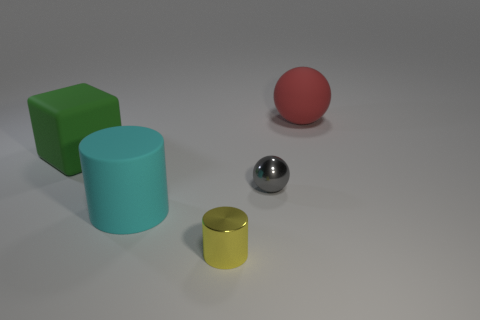Are there any big green matte blocks to the right of the tiny gray sphere?
Give a very brief answer. No. Are there more red matte things that are behind the tiny metal cylinder than big yellow cylinders?
Provide a succinct answer. Yes. There is a matte sphere that is the same size as the matte cylinder; what is its color?
Your answer should be very brief. Red. Are there any green rubber things that are behind the sphere left of the red matte object?
Your answer should be very brief. Yes. There is a sphere that is behind the matte block; what is its material?
Offer a terse response. Rubber. Does the small thing that is behind the yellow metallic cylinder have the same material as the cylinder behind the yellow metallic cylinder?
Your answer should be compact. No. Is the number of large cylinders that are behind the red thing the same as the number of small yellow cylinders that are behind the yellow metal object?
Your answer should be compact. Yes. How many yellow things have the same material as the gray object?
Your answer should be compact. 1. What is the size of the ball that is behind the tiny object behind the metal cylinder?
Your answer should be compact. Large. There is a small thing that is behind the shiny cylinder; is it the same shape as the large object to the right of the cyan rubber cylinder?
Keep it short and to the point. Yes. 